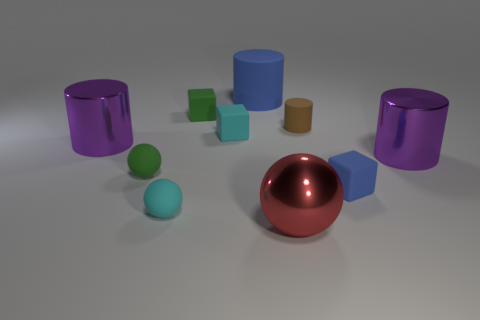How many purple cylinders must be subtracted to get 1 purple cylinders? 1 Subtract all small blue blocks. How many blocks are left? 2 Subtract all red spheres. How many spheres are left? 2 Subtract 1 balls. How many balls are left? 2 Subtract all gray blocks. How many brown cylinders are left? 1 Subtract all gray rubber things. Subtract all cyan objects. How many objects are left? 8 Add 7 tiny matte cubes. How many tiny matte cubes are left? 10 Add 1 cyan rubber balls. How many cyan rubber balls exist? 2 Subtract 0 cyan cylinders. How many objects are left? 10 Subtract all blocks. How many objects are left? 7 